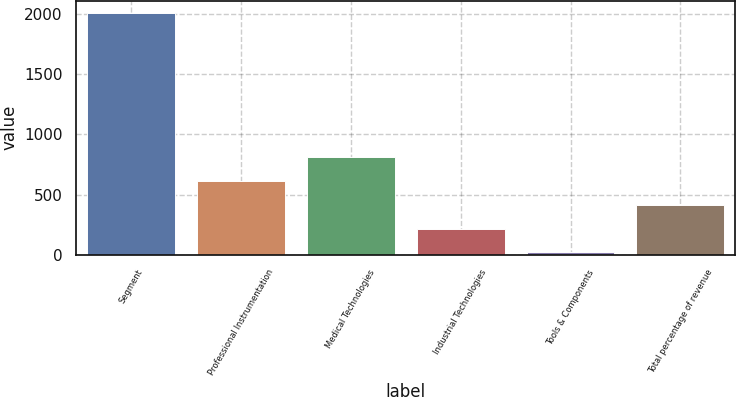Convert chart. <chart><loc_0><loc_0><loc_500><loc_500><bar_chart><fcel>Segment<fcel>Professional Instrumentation<fcel>Medical Technologies<fcel>Industrial Technologies<fcel>Tools & Components<fcel>Total percentage of revenue<nl><fcel>2008<fcel>615.7<fcel>814.6<fcel>217.9<fcel>19<fcel>416.8<nl></chart> 